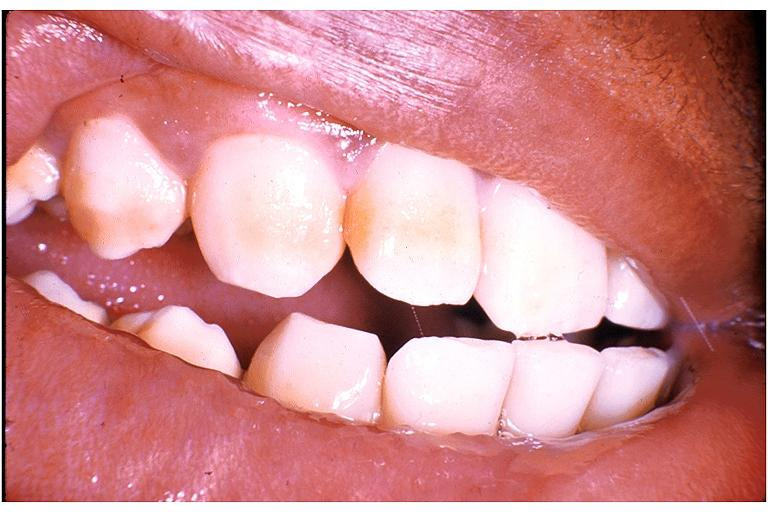s oral present?
Answer the question using a single word or phrase. Yes 